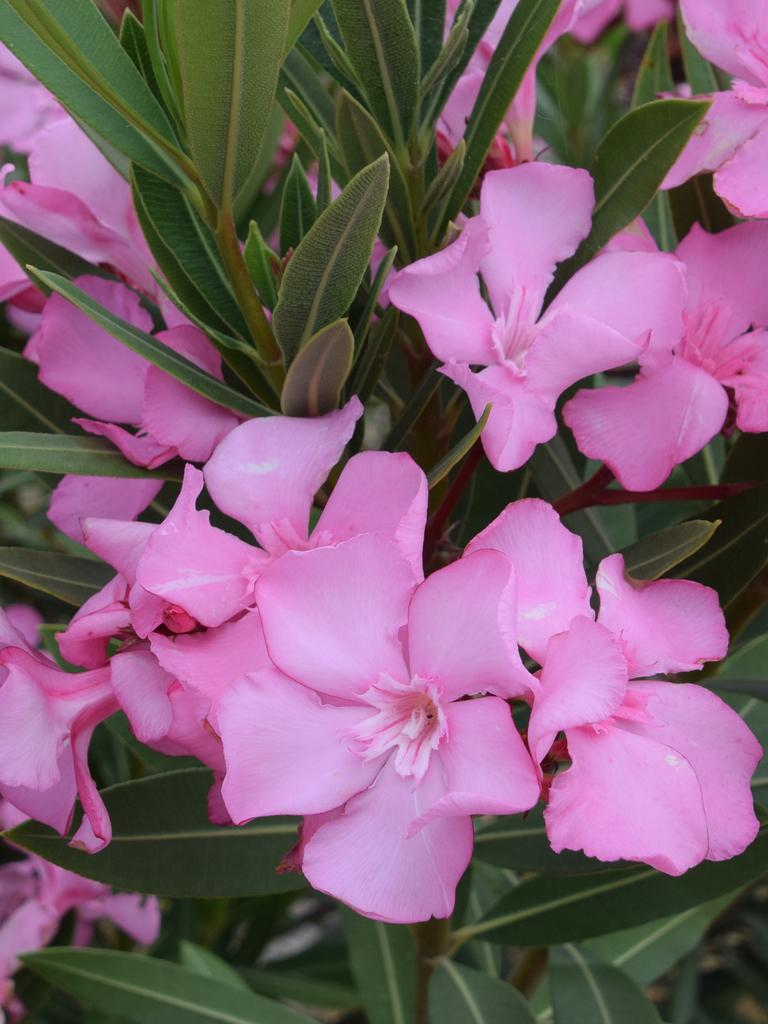What type of flora can be seen in the image? There are flowers and plants in the image. What color are the flowers in the image? The flowers in the image are pink in color. What color are the plants in the image? The plants in the image are green in color. Can you see the wings of the porter in the image? There is no porter or wings present in the image; it features flowers and plants. 